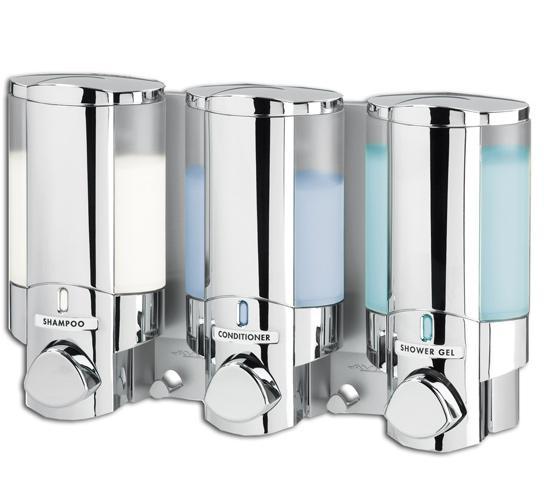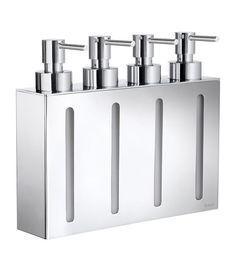The first image is the image on the left, the second image is the image on the right. Assess this claim about the two images: "At least one image shows a chrome rack with a suspended round scrubber, between two dispensers.". Correct or not? Answer yes or no. No. The first image is the image on the left, the second image is the image on the right. Considering the images on both sides, is "Each image contains at least three dispensers in a line." valid? Answer yes or no. Yes. 